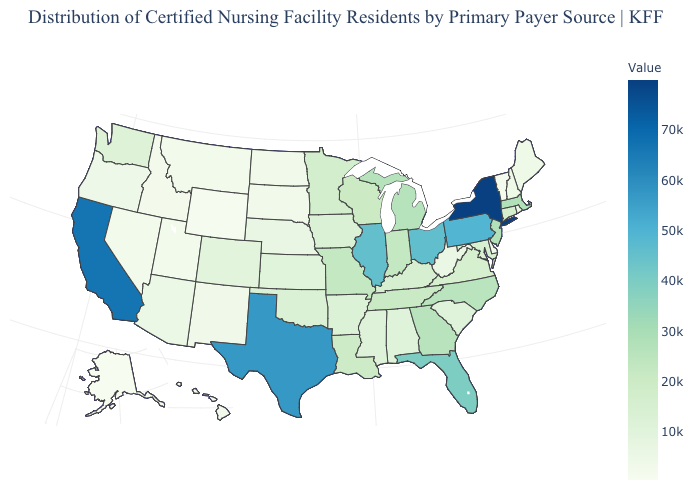Which states have the lowest value in the USA?
Short answer required. Alaska. Does the map have missing data?
Write a very short answer. No. Which states have the lowest value in the USA?
Short answer required. Alaska. Which states hav the highest value in the MidWest?
Be succinct. Ohio. Which states have the lowest value in the West?
Quick response, please. Alaska. Among the states that border Kentucky , which have the lowest value?
Quick response, please. West Virginia. Among the states that border Connecticut , does Rhode Island have the lowest value?
Concise answer only. Yes. 